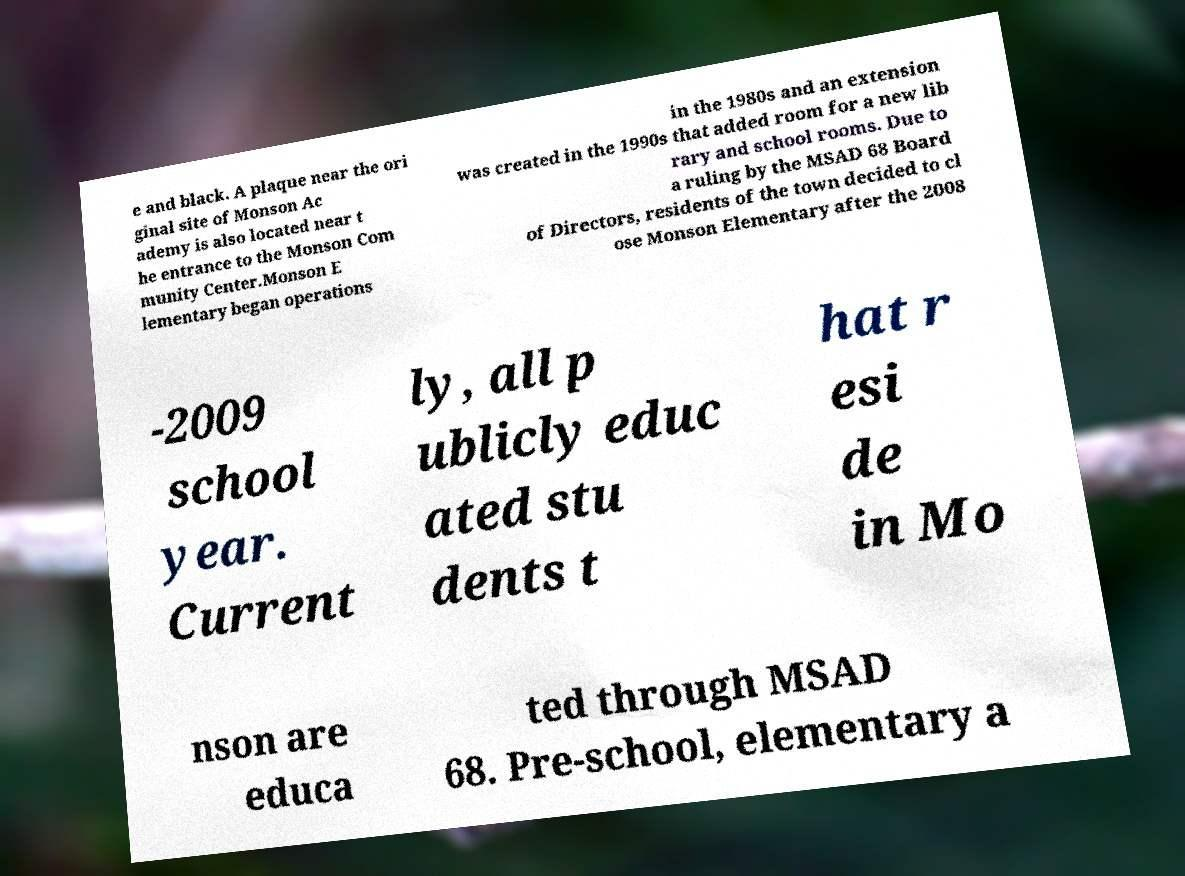Can you read and provide the text displayed in the image?This photo seems to have some interesting text. Can you extract and type it out for me? e and black. A plaque near the ori ginal site of Monson Ac ademy is also located near t he entrance to the Monson Com munity Center.Monson E lementary began operations in the 1980s and an extension was created in the 1990s that added room for a new lib rary and school rooms. Due to a ruling by the MSAD 68 Board of Directors, residents of the town decided to cl ose Monson Elementary after the 2008 -2009 school year. Current ly, all p ublicly educ ated stu dents t hat r esi de in Mo nson are educa ted through MSAD 68. Pre-school, elementary a 